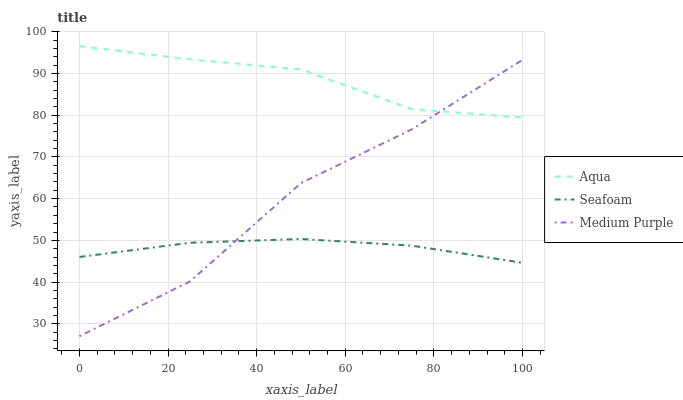Does Aqua have the minimum area under the curve?
Answer yes or no. No. Does Seafoam have the maximum area under the curve?
Answer yes or no. No. Is Aqua the smoothest?
Answer yes or no. No. Is Aqua the roughest?
Answer yes or no. No. Does Seafoam have the lowest value?
Answer yes or no. No. Does Seafoam have the highest value?
Answer yes or no. No. Is Seafoam less than Aqua?
Answer yes or no. Yes. Is Aqua greater than Seafoam?
Answer yes or no. Yes. Does Seafoam intersect Aqua?
Answer yes or no. No. 